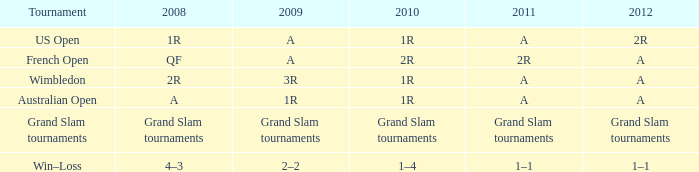Name the 2010 for 2011 of a and 2008 of 1r 1R. 